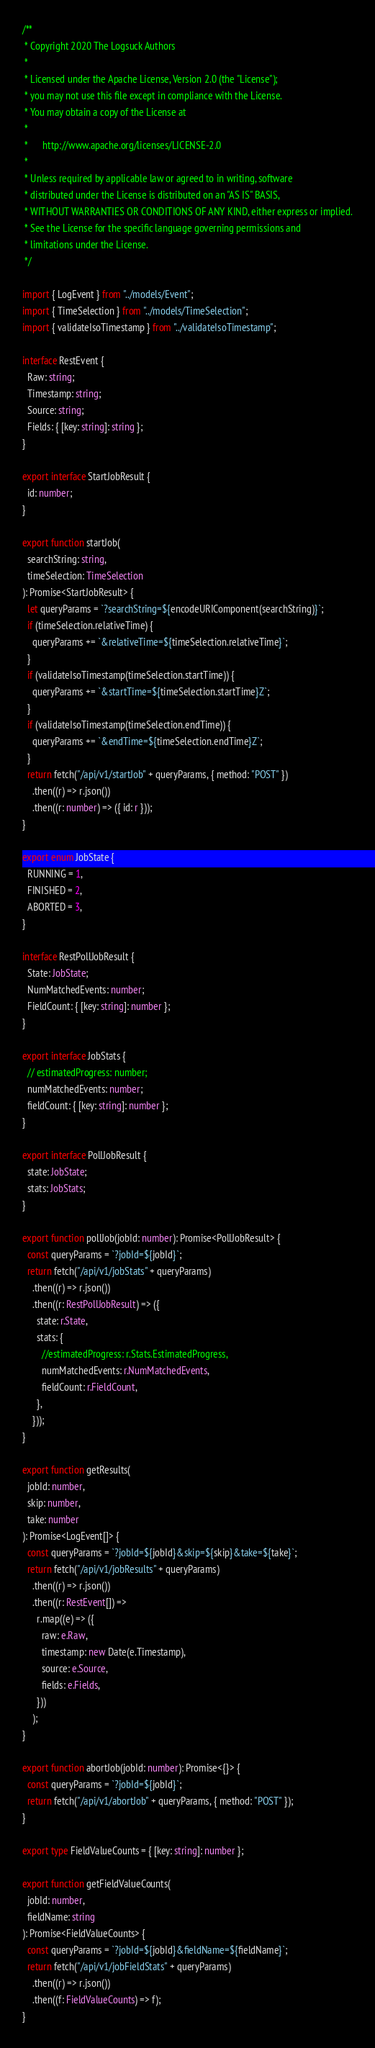<code> <loc_0><loc_0><loc_500><loc_500><_TypeScript_>/**
 * Copyright 2020 The Logsuck Authors
 *
 * Licensed under the Apache License, Version 2.0 (the "License");
 * you may not use this file except in compliance with the License.
 * You may obtain a copy of the License at
 *
 *      http://www.apache.org/licenses/LICENSE-2.0
 *
 * Unless required by applicable law or agreed to in writing, software
 * distributed under the License is distributed on an "AS IS" BASIS,
 * WITHOUT WARRANTIES OR CONDITIONS OF ANY KIND, either express or implied.
 * See the License for the specific language governing permissions and
 * limitations under the License.
 */

import { LogEvent } from "../models/Event";
import { TimeSelection } from "../models/TimeSelection";
import { validateIsoTimestamp } from "../validateIsoTimestamp";

interface RestEvent {
  Raw: string;
  Timestamp: string;
  Source: string;
  Fields: { [key: string]: string };
}

export interface StartJobResult {
  id: number;
}

export function startJob(
  searchString: string,
  timeSelection: TimeSelection
): Promise<StartJobResult> {
  let queryParams = `?searchString=${encodeURIComponent(searchString)}`;
  if (timeSelection.relativeTime) {
    queryParams += `&relativeTime=${timeSelection.relativeTime}`;
  }
  if (validateIsoTimestamp(timeSelection.startTime)) {
    queryParams += `&startTime=${timeSelection.startTime}Z`;
  }
  if (validateIsoTimestamp(timeSelection.endTime)) {
    queryParams += `&endTime=${timeSelection.endTime}Z`;
  }
  return fetch("/api/v1/startJob" + queryParams, { method: "POST" })
    .then((r) => r.json())
    .then((r: number) => ({ id: r }));
}

export enum JobState {
  RUNNING = 1,
  FINISHED = 2,
  ABORTED = 3,
}

interface RestPollJobResult {
  State: JobState;
  NumMatchedEvents: number;
  FieldCount: { [key: string]: number };
}

export interface JobStats {
  // estimatedProgress: number;
  numMatchedEvents: number;
  fieldCount: { [key: string]: number };
}

export interface PollJobResult {
  state: JobState;
  stats: JobStats;
}

export function pollJob(jobId: number): Promise<PollJobResult> {
  const queryParams = `?jobId=${jobId}`;
  return fetch("/api/v1/jobStats" + queryParams)
    .then((r) => r.json())
    .then((r: RestPollJobResult) => ({
      state: r.State,
      stats: {
        //estimatedProgress: r.Stats.EstimatedProgress,
        numMatchedEvents: r.NumMatchedEvents,
        fieldCount: r.FieldCount,
      },
    }));
}

export function getResults(
  jobId: number,
  skip: number,
  take: number
): Promise<LogEvent[]> {
  const queryParams = `?jobId=${jobId}&skip=${skip}&take=${take}`;
  return fetch("/api/v1/jobResults" + queryParams)
    .then((r) => r.json())
    .then((r: RestEvent[]) =>
      r.map((e) => ({
        raw: e.Raw,
        timestamp: new Date(e.Timestamp),
        source: e.Source,
        fields: e.Fields,
      }))
    );
}

export function abortJob(jobId: number): Promise<{}> {
  const queryParams = `?jobId=${jobId}`;
  return fetch("/api/v1/abortJob" + queryParams, { method: "POST" });
}

export type FieldValueCounts = { [key: string]: number };

export function getFieldValueCounts(
  jobId: number,
  fieldName: string
): Promise<FieldValueCounts> {
  const queryParams = `?jobId=${jobId}&fieldName=${fieldName}`;
  return fetch("/api/v1/jobFieldStats" + queryParams)
    .then((r) => r.json())
    .then((f: FieldValueCounts) => f);
}
</code> 